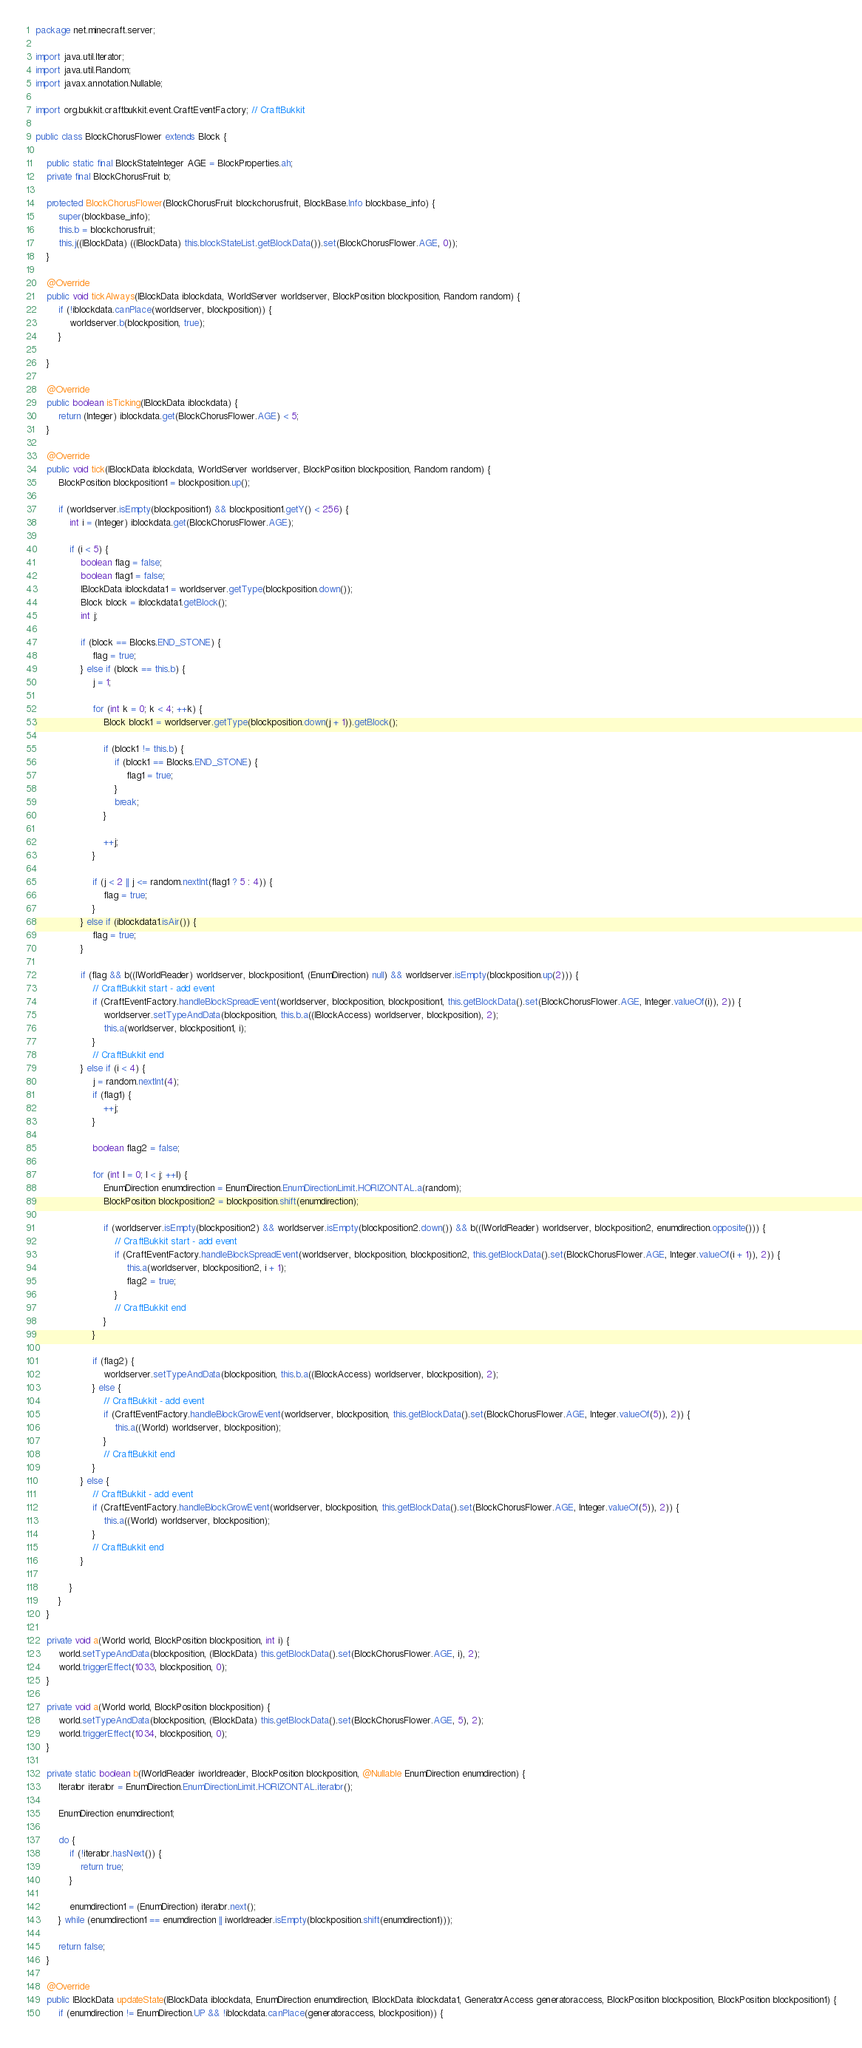<code> <loc_0><loc_0><loc_500><loc_500><_Java_>package net.minecraft.server;

import java.util.Iterator;
import java.util.Random;
import javax.annotation.Nullable;

import org.bukkit.craftbukkit.event.CraftEventFactory; // CraftBukkit

public class BlockChorusFlower extends Block {

    public static final BlockStateInteger AGE = BlockProperties.ah;
    private final BlockChorusFruit b;

    protected BlockChorusFlower(BlockChorusFruit blockchorusfruit, BlockBase.Info blockbase_info) {
        super(blockbase_info);
        this.b = blockchorusfruit;
        this.j((IBlockData) ((IBlockData) this.blockStateList.getBlockData()).set(BlockChorusFlower.AGE, 0));
    }

    @Override
    public void tickAlways(IBlockData iblockdata, WorldServer worldserver, BlockPosition blockposition, Random random) {
        if (!iblockdata.canPlace(worldserver, blockposition)) {
            worldserver.b(blockposition, true);
        }

    }

    @Override
    public boolean isTicking(IBlockData iblockdata) {
        return (Integer) iblockdata.get(BlockChorusFlower.AGE) < 5;
    }

    @Override
    public void tick(IBlockData iblockdata, WorldServer worldserver, BlockPosition blockposition, Random random) {
        BlockPosition blockposition1 = blockposition.up();

        if (worldserver.isEmpty(blockposition1) && blockposition1.getY() < 256) {
            int i = (Integer) iblockdata.get(BlockChorusFlower.AGE);

            if (i < 5) {
                boolean flag = false;
                boolean flag1 = false;
                IBlockData iblockdata1 = worldserver.getType(blockposition.down());
                Block block = iblockdata1.getBlock();
                int j;

                if (block == Blocks.END_STONE) {
                    flag = true;
                } else if (block == this.b) {
                    j = 1;

                    for (int k = 0; k < 4; ++k) {
                        Block block1 = worldserver.getType(blockposition.down(j + 1)).getBlock();

                        if (block1 != this.b) {
                            if (block1 == Blocks.END_STONE) {
                                flag1 = true;
                            }
                            break;
                        }

                        ++j;
                    }

                    if (j < 2 || j <= random.nextInt(flag1 ? 5 : 4)) {
                        flag = true;
                    }
                } else if (iblockdata1.isAir()) {
                    flag = true;
                }

                if (flag && b((IWorldReader) worldserver, blockposition1, (EnumDirection) null) && worldserver.isEmpty(blockposition.up(2))) {
                    // CraftBukkit start - add event
                    if (CraftEventFactory.handleBlockSpreadEvent(worldserver, blockposition, blockposition1, this.getBlockData().set(BlockChorusFlower.AGE, Integer.valueOf(i)), 2)) {
                        worldserver.setTypeAndData(blockposition, this.b.a((IBlockAccess) worldserver, blockposition), 2);
                        this.a(worldserver, blockposition1, i);
                    }
                    // CraftBukkit end
                } else if (i < 4) {
                    j = random.nextInt(4);
                    if (flag1) {
                        ++j;
                    }

                    boolean flag2 = false;

                    for (int l = 0; l < j; ++l) {
                        EnumDirection enumdirection = EnumDirection.EnumDirectionLimit.HORIZONTAL.a(random);
                        BlockPosition blockposition2 = blockposition.shift(enumdirection);

                        if (worldserver.isEmpty(blockposition2) && worldserver.isEmpty(blockposition2.down()) && b((IWorldReader) worldserver, blockposition2, enumdirection.opposite())) {
                            // CraftBukkit start - add event
                            if (CraftEventFactory.handleBlockSpreadEvent(worldserver, blockposition, blockposition2, this.getBlockData().set(BlockChorusFlower.AGE, Integer.valueOf(i + 1)), 2)) {
                                this.a(worldserver, blockposition2, i + 1);
                                flag2 = true;
                            }
                            // CraftBukkit end
                        }
                    }

                    if (flag2) {
                        worldserver.setTypeAndData(blockposition, this.b.a((IBlockAccess) worldserver, blockposition), 2);
                    } else {
                        // CraftBukkit - add event
                        if (CraftEventFactory.handleBlockGrowEvent(worldserver, blockposition, this.getBlockData().set(BlockChorusFlower.AGE, Integer.valueOf(5)), 2)) {
                            this.a((World) worldserver, blockposition);
                        }
                        // CraftBukkit end
                    }
                } else {
                    // CraftBukkit - add event
                    if (CraftEventFactory.handleBlockGrowEvent(worldserver, blockposition, this.getBlockData().set(BlockChorusFlower.AGE, Integer.valueOf(5)), 2)) {
                        this.a((World) worldserver, blockposition);
                    }
                    // CraftBukkit end
                }

            }
        }
    }

    private void a(World world, BlockPosition blockposition, int i) {
        world.setTypeAndData(blockposition, (IBlockData) this.getBlockData().set(BlockChorusFlower.AGE, i), 2);
        world.triggerEffect(1033, blockposition, 0);
    }

    private void a(World world, BlockPosition blockposition) {
        world.setTypeAndData(blockposition, (IBlockData) this.getBlockData().set(BlockChorusFlower.AGE, 5), 2);
        world.triggerEffect(1034, blockposition, 0);
    }

    private static boolean b(IWorldReader iworldreader, BlockPosition blockposition, @Nullable EnumDirection enumdirection) {
        Iterator iterator = EnumDirection.EnumDirectionLimit.HORIZONTAL.iterator();

        EnumDirection enumdirection1;

        do {
            if (!iterator.hasNext()) {
                return true;
            }

            enumdirection1 = (EnumDirection) iterator.next();
        } while (enumdirection1 == enumdirection || iworldreader.isEmpty(blockposition.shift(enumdirection1)));

        return false;
    }

    @Override
    public IBlockData updateState(IBlockData iblockdata, EnumDirection enumdirection, IBlockData iblockdata1, GeneratorAccess generatoraccess, BlockPosition blockposition, BlockPosition blockposition1) {
        if (enumdirection != EnumDirection.UP && !iblockdata.canPlace(generatoraccess, blockposition)) {</code> 